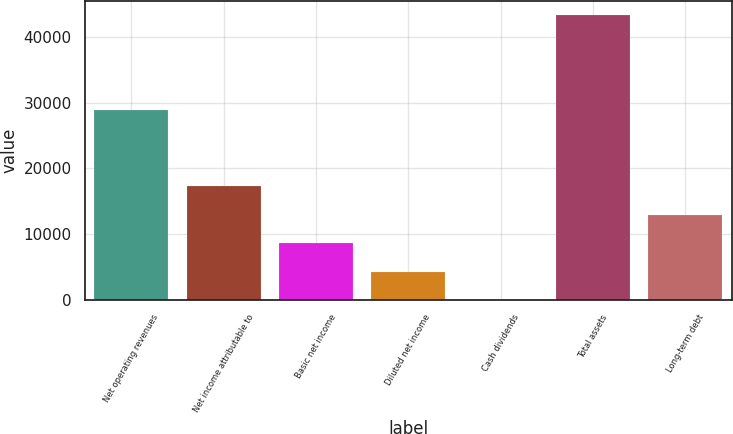<chart> <loc_0><loc_0><loc_500><loc_500><bar_chart><fcel>Net operating revenues<fcel>Net income attributable to<fcel>Basic net income<fcel>Diluted net income<fcel>Cash dividends<fcel>Total assets<fcel>Long-term debt<nl><fcel>28857<fcel>17308.4<fcel>8654.88<fcel>4328.12<fcel>1.36<fcel>43269<fcel>12981.6<nl></chart> 